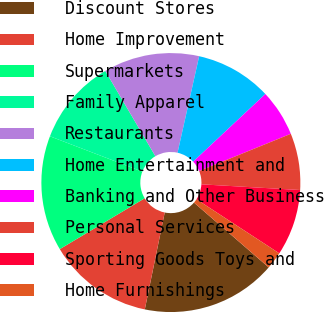<chart> <loc_0><loc_0><loc_500><loc_500><pie_chart><fcel>Discount Stores<fcel>Home Improvement<fcel>Supermarkets<fcel>Family Apparel<fcel>Restaurants<fcel>Home Entertainment and<fcel>Banking and Other Business<fcel>Personal Services<fcel>Sporting Goods Toys and<fcel>Home Furnishings<nl><fcel>16.86%<fcel>13.18%<fcel>14.41%<fcel>10.73%<fcel>11.96%<fcel>9.51%<fcel>5.84%<fcel>7.06%<fcel>8.29%<fcel>2.16%<nl></chart> 